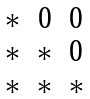Convert formula to latex. <formula><loc_0><loc_0><loc_500><loc_500>\begin{matrix} * & 0 & 0 \\ * & * & 0 \\ * & * & * \end{matrix}</formula> 